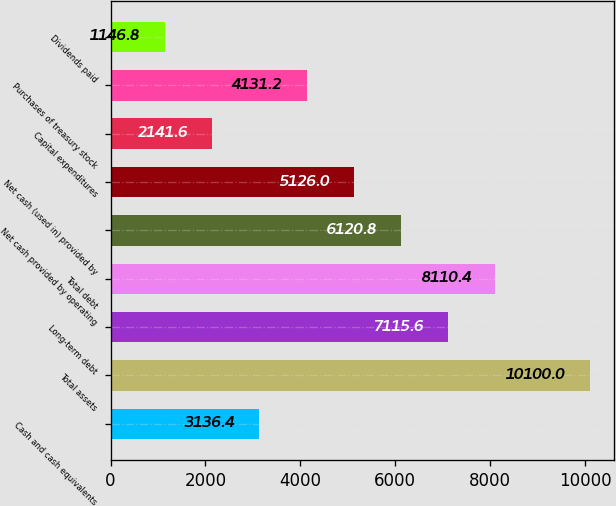Convert chart to OTSL. <chart><loc_0><loc_0><loc_500><loc_500><bar_chart><fcel>Cash and cash equivalents<fcel>Total assets<fcel>Long-term debt<fcel>Total debt<fcel>Net cash provided by operating<fcel>Net cash (used in) provided by<fcel>Capital expenditures<fcel>Purchases of treasury stock<fcel>Dividends paid<nl><fcel>3136.4<fcel>10100<fcel>7115.6<fcel>8110.4<fcel>6120.8<fcel>5126<fcel>2141.6<fcel>4131.2<fcel>1146.8<nl></chart> 